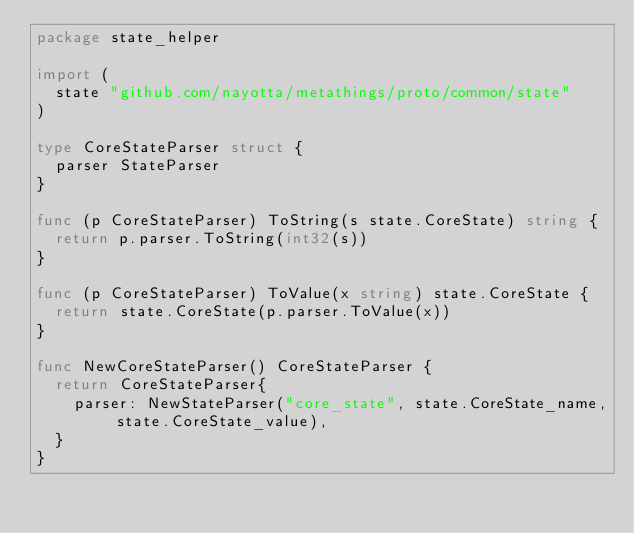Convert code to text. <code><loc_0><loc_0><loc_500><loc_500><_Go_>package state_helper

import (
	state "github.com/nayotta/metathings/proto/common/state"
)

type CoreStateParser struct {
	parser StateParser
}

func (p CoreStateParser) ToString(s state.CoreState) string {
	return p.parser.ToString(int32(s))
}

func (p CoreStateParser) ToValue(x string) state.CoreState {
	return state.CoreState(p.parser.ToValue(x))
}

func NewCoreStateParser() CoreStateParser {
	return CoreStateParser{
		parser: NewStateParser("core_state", state.CoreState_name, state.CoreState_value),
	}
}
</code> 